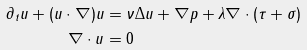Convert formula to latex. <formula><loc_0><loc_0><loc_500><loc_500>\partial _ { t } u + ( u \cdot \nabla ) u & = \nu \Delta u + \nabla p + \lambda \nabla \cdot ( \tau + \sigma ) \\ \nabla \cdot u & = 0</formula> 